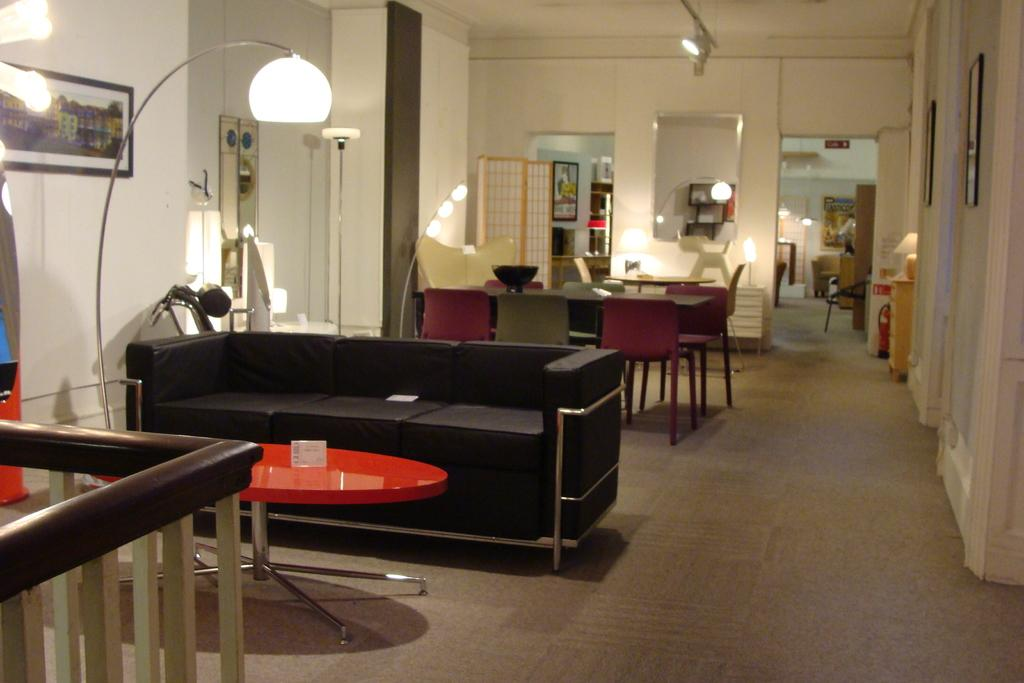What type of furniture is present in the image? There is a table and a sofa in the image. What is the purpose of the table in the image? There is a dining table in the image, which is used for eating meals. What is placed on the dining table? There is a bowl on the dining table. What is on the wall in the image? There is a photo frame on the wall. What type of lighting is present in the image? There is a light in the image. What architectural feature is present in the image? There is a door in the image. How many cherries are on top of the jam in the image? There are no cherries or jam present in the image. 